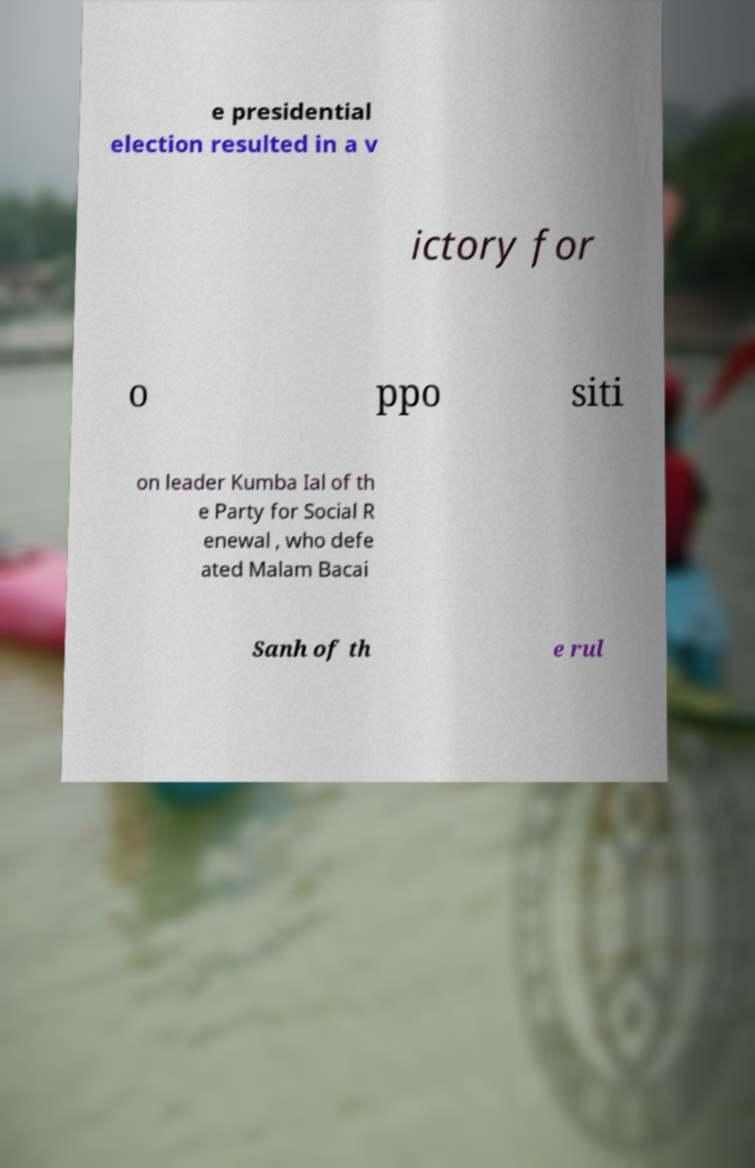There's text embedded in this image that I need extracted. Can you transcribe it verbatim? e presidential election resulted in a v ictory for o ppo siti on leader Kumba Ial of th e Party for Social R enewal , who defe ated Malam Bacai Sanh of th e rul 